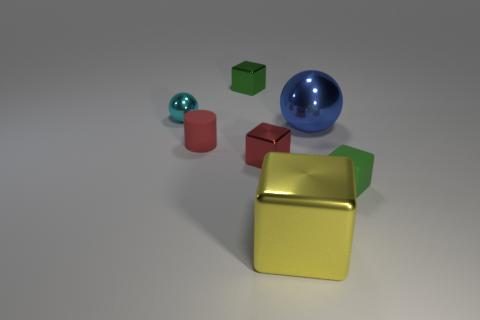Subtract all large metallic blocks. How many blocks are left? 3 Subtract all red blocks. How many blocks are left? 3 Add 3 small objects. How many objects exist? 10 Subtract 2 blocks. How many blocks are left? 2 Subtract all cylinders. How many objects are left? 6 Subtract all cyan cubes. Subtract all yellow cylinders. How many cubes are left? 4 Subtract all red cylinders. How many green cubes are left? 2 Subtract all tiny blue metal blocks. Subtract all yellow metallic cubes. How many objects are left? 6 Add 2 metallic balls. How many metallic balls are left? 4 Add 3 tiny matte blocks. How many tiny matte blocks exist? 4 